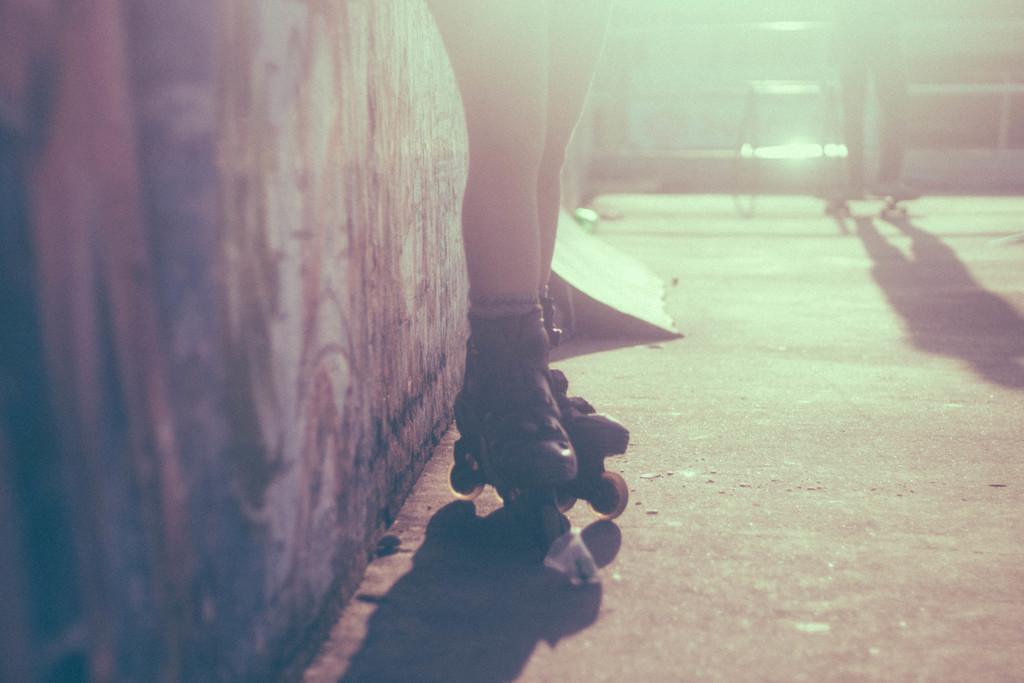Describe this image in one or two sentences. In this image there is skating area in that area there are two persons skating, on the left side there is wall. 